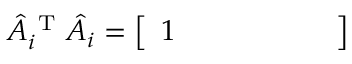Convert formula to latex. <formula><loc_0><loc_0><loc_500><loc_500>\hat { A } _ { i } ^ { T } \hat { A } _ { i } = \left [ \begin{array} { l l l l l l } { 1 } \end{array} \right ]</formula> 